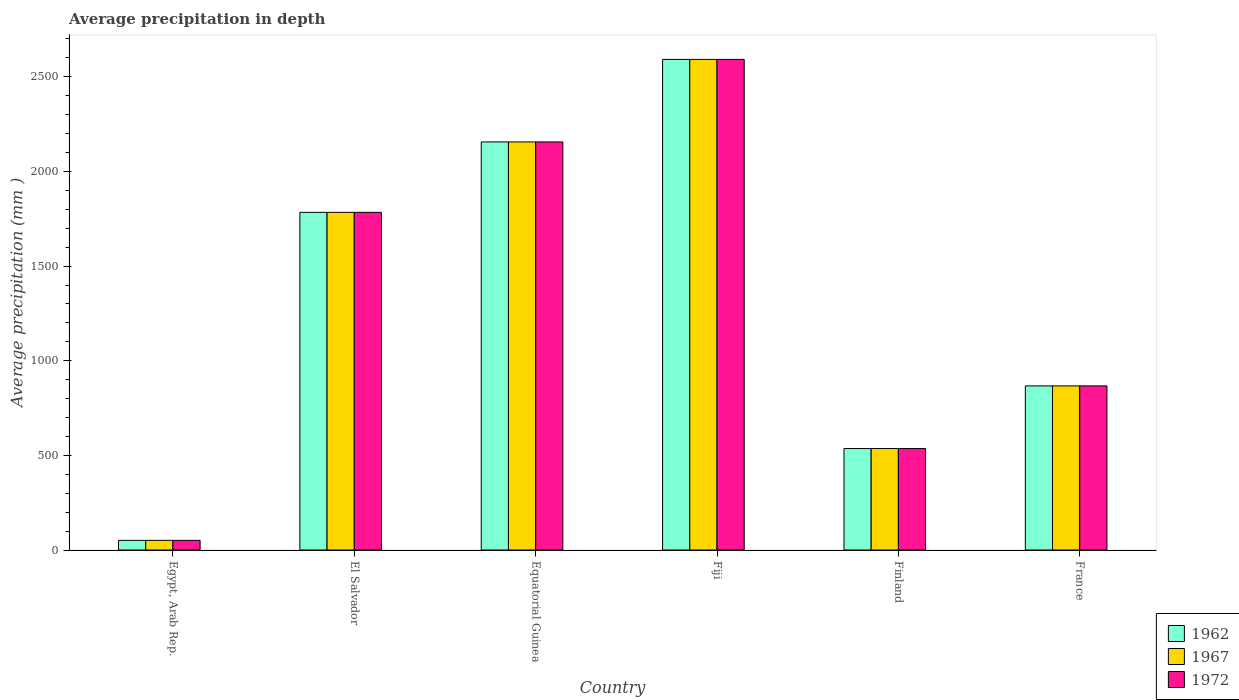Are the number of bars on each tick of the X-axis equal?
Provide a succinct answer. Yes. How many bars are there on the 4th tick from the right?
Make the answer very short. 3. What is the label of the 4th group of bars from the left?
Provide a short and direct response. Fiji. What is the average precipitation in 1962 in Equatorial Guinea?
Give a very brief answer. 2156. Across all countries, what is the maximum average precipitation in 1967?
Your answer should be very brief. 2592. Across all countries, what is the minimum average precipitation in 1962?
Offer a very short reply. 51. In which country was the average precipitation in 1967 maximum?
Your answer should be compact. Fiji. In which country was the average precipitation in 1962 minimum?
Give a very brief answer. Egypt, Arab Rep. What is the total average precipitation in 1962 in the graph?
Your answer should be very brief. 7986. What is the difference between the average precipitation in 1967 in El Salvador and that in Fiji?
Ensure brevity in your answer.  -808. What is the difference between the average precipitation in 1972 in Equatorial Guinea and the average precipitation in 1962 in Fiji?
Your response must be concise. -436. What is the average average precipitation in 1967 per country?
Keep it short and to the point. 1331. What is the difference between the average precipitation of/in 1967 and average precipitation of/in 1972 in Finland?
Your answer should be very brief. 0. In how many countries, is the average precipitation in 1972 greater than 500 mm?
Your answer should be very brief. 5. What is the ratio of the average precipitation in 1962 in El Salvador to that in Equatorial Guinea?
Keep it short and to the point. 0.83. Is the difference between the average precipitation in 1967 in Equatorial Guinea and France greater than the difference between the average precipitation in 1972 in Equatorial Guinea and France?
Your answer should be very brief. No. What is the difference between the highest and the second highest average precipitation in 1967?
Offer a terse response. 808. What is the difference between the highest and the lowest average precipitation in 1967?
Give a very brief answer. 2541. In how many countries, is the average precipitation in 1962 greater than the average average precipitation in 1962 taken over all countries?
Provide a succinct answer. 3. Is the sum of the average precipitation in 1972 in Fiji and France greater than the maximum average precipitation in 1962 across all countries?
Your response must be concise. Yes. What does the 3rd bar from the left in Equatorial Guinea represents?
Make the answer very short. 1972. How many bars are there?
Offer a terse response. 18. Are all the bars in the graph horizontal?
Your answer should be very brief. No. How many countries are there in the graph?
Offer a terse response. 6. Where does the legend appear in the graph?
Ensure brevity in your answer.  Bottom right. How are the legend labels stacked?
Keep it short and to the point. Vertical. What is the title of the graph?
Offer a terse response. Average precipitation in depth. Does "2007" appear as one of the legend labels in the graph?
Give a very brief answer. No. What is the label or title of the X-axis?
Make the answer very short. Country. What is the label or title of the Y-axis?
Make the answer very short. Average precipitation (mm ). What is the Average precipitation (mm ) in 1972 in Egypt, Arab Rep.?
Provide a short and direct response. 51. What is the Average precipitation (mm ) in 1962 in El Salvador?
Your response must be concise. 1784. What is the Average precipitation (mm ) in 1967 in El Salvador?
Your answer should be compact. 1784. What is the Average precipitation (mm ) of 1972 in El Salvador?
Give a very brief answer. 1784. What is the Average precipitation (mm ) of 1962 in Equatorial Guinea?
Make the answer very short. 2156. What is the Average precipitation (mm ) in 1967 in Equatorial Guinea?
Offer a terse response. 2156. What is the Average precipitation (mm ) of 1972 in Equatorial Guinea?
Provide a succinct answer. 2156. What is the Average precipitation (mm ) in 1962 in Fiji?
Your answer should be compact. 2592. What is the Average precipitation (mm ) of 1967 in Fiji?
Offer a terse response. 2592. What is the Average precipitation (mm ) of 1972 in Fiji?
Offer a very short reply. 2592. What is the Average precipitation (mm ) in 1962 in Finland?
Offer a very short reply. 536. What is the Average precipitation (mm ) in 1967 in Finland?
Provide a succinct answer. 536. What is the Average precipitation (mm ) in 1972 in Finland?
Your answer should be compact. 536. What is the Average precipitation (mm ) in 1962 in France?
Ensure brevity in your answer.  867. What is the Average precipitation (mm ) of 1967 in France?
Offer a very short reply. 867. What is the Average precipitation (mm ) in 1972 in France?
Provide a short and direct response. 867. Across all countries, what is the maximum Average precipitation (mm ) in 1962?
Keep it short and to the point. 2592. Across all countries, what is the maximum Average precipitation (mm ) of 1967?
Provide a succinct answer. 2592. Across all countries, what is the maximum Average precipitation (mm ) in 1972?
Provide a short and direct response. 2592. Across all countries, what is the minimum Average precipitation (mm ) of 1967?
Offer a very short reply. 51. Across all countries, what is the minimum Average precipitation (mm ) of 1972?
Provide a succinct answer. 51. What is the total Average precipitation (mm ) in 1962 in the graph?
Your response must be concise. 7986. What is the total Average precipitation (mm ) of 1967 in the graph?
Give a very brief answer. 7986. What is the total Average precipitation (mm ) of 1972 in the graph?
Keep it short and to the point. 7986. What is the difference between the Average precipitation (mm ) of 1962 in Egypt, Arab Rep. and that in El Salvador?
Your response must be concise. -1733. What is the difference between the Average precipitation (mm ) of 1967 in Egypt, Arab Rep. and that in El Salvador?
Your answer should be compact. -1733. What is the difference between the Average precipitation (mm ) of 1972 in Egypt, Arab Rep. and that in El Salvador?
Provide a short and direct response. -1733. What is the difference between the Average precipitation (mm ) in 1962 in Egypt, Arab Rep. and that in Equatorial Guinea?
Offer a terse response. -2105. What is the difference between the Average precipitation (mm ) in 1967 in Egypt, Arab Rep. and that in Equatorial Guinea?
Offer a terse response. -2105. What is the difference between the Average precipitation (mm ) in 1972 in Egypt, Arab Rep. and that in Equatorial Guinea?
Offer a terse response. -2105. What is the difference between the Average precipitation (mm ) of 1962 in Egypt, Arab Rep. and that in Fiji?
Keep it short and to the point. -2541. What is the difference between the Average precipitation (mm ) in 1967 in Egypt, Arab Rep. and that in Fiji?
Provide a short and direct response. -2541. What is the difference between the Average precipitation (mm ) of 1972 in Egypt, Arab Rep. and that in Fiji?
Ensure brevity in your answer.  -2541. What is the difference between the Average precipitation (mm ) in 1962 in Egypt, Arab Rep. and that in Finland?
Your answer should be compact. -485. What is the difference between the Average precipitation (mm ) of 1967 in Egypt, Arab Rep. and that in Finland?
Ensure brevity in your answer.  -485. What is the difference between the Average precipitation (mm ) in 1972 in Egypt, Arab Rep. and that in Finland?
Your answer should be compact. -485. What is the difference between the Average precipitation (mm ) of 1962 in Egypt, Arab Rep. and that in France?
Your answer should be very brief. -816. What is the difference between the Average precipitation (mm ) in 1967 in Egypt, Arab Rep. and that in France?
Your answer should be very brief. -816. What is the difference between the Average precipitation (mm ) in 1972 in Egypt, Arab Rep. and that in France?
Offer a very short reply. -816. What is the difference between the Average precipitation (mm ) in 1962 in El Salvador and that in Equatorial Guinea?
Give a very brief answer. -372. What is the difference between the Average precipitation (mm ) in 1967 in El Salvador and that in Equatorial Guinea?
Provide a short and direct response. -372. What is the difference between the Average precipitation (mm ) of 1972 in El Salvador and that in Equatorial Guinea?
Your answer should be compact. -372. What is the difference between the Average precipitation (mm ) in 1962 in El Salvador and that in Fiji?
Ensure brevity in your answer.  -808. What is the difference between the Average precipitation (mm ) of 1967 in El Salvador and that in Fiji?
Your answer should be compact. -808. What is the difference between the Average precipitation (mm ) of 1972 in El Salvador and that in Fiji?
Provide a short and direct response. -808. What is the difference between the Average precipitation (mm ) in 1962 in El Salvador and that in Finland?
Make the answer very short. 1248. What is the difference between the Average precipitation (mm ) in 1967 in El Salvador and that in Finland?
Provide a succinct answer. 1248. What is the difference between the Average precipitation (mm ) in 1972 in El Salvador and that in Finland?
Provide a succinct answer. 1248. What is the difference between the Average precipitation (mm ) in 1962 in El Salvador and that in France?
Make the answer very short. 917. What is the difference between the Average precipitation (mm ) of 1967 in El Salvador and that in France?
Offer a terse response. 917. What is the difference between the Average precipitation (mm ) in 1972 in El Salvador and that in France?
Provide a short and direct response. 917. What is the difference between the Average precipitation (mm ) in 1962 in Equatorial Guinea and that in Fiji?
Provide a succinct answer. -436. What is the difference between the Average precipitation (mm ) in 1967 in Equatorial Guinea and that in Fiji?
Provide a short and direct response. -436. What is the difference between the Average precipitation (mm ) in 1972 in Equatorial Guinea and that in Fiji?
Your answer should be very brief. -436. What is the difference between the Average precipitation (mm ) in 1962 in Equatorial Guinea and that in Finland?
Offer a very short reply. 1620. What is the difference between the Average precipitation (mm ) of 1967 in Equatorial Guinea and that in Finland?
Offer a terse response. 1620. What is the difference between the Average precipitation (mm ) in 1972 in Equatorial Guinea and that in Finland?
Your answer should be very brief. 1620. What is the difference between the Average precipitation (mm ) in 1962 in Equatorial Guinea and that in France?
Offer a terse response. 1289. What is the difference between the Average precipitation (mm ) in 1967 in Equatorial Guinea and that in France?
Give a very brief answer. 1289. What is the difference between the Average precipitation (mm ) of 1972 in Equatorial Guinea and that in France?
Ensure brevity in your answer.  1289. What is the difference between the Average precipitation (mm ) in 1962 in Fiji and that in Finland?
Keep it short and to the point. 2056. What is the difference between the Average precipitation (mm ) of 1967 in Fiji and that in Finland?
Your response must be concise. 2056. What is the difference between the Average precipitation (mm ) in 1972 in Fiji and that in Finland?
Ensure brevity in your answer.  2056. What is the difference between the Average precipitation (mm ) in 1962 in Fiji and that in France?
Give a very brief answer. 1725. What is the difference between the Average precipitation (mm ) of 1967 in Fiji and that in France?
Make the answer very short. 1725. What is the difference between the Average precipitation (mm ) in 1972 in Fiji and that in France?
Make the answer very short. 1725. What is the difference between the Average precipitation (mm ) of 1962 in Finland and that in France?
Your answer should be compact. -331. What is the difference between the Average precipitation (mm ) in 1967 in Finland and that in France?
Provide a short and direct response. -331. What is the difference between the Average precipitation (mm ) of 1972 in Finland and that in France?
Offer a terse response. -331. What is the difference between the Average precipitation (mm ) in 1962 in Egypt, Arab Rep. and the Average precipitation (mm ) in 1967 in El Salvador?
Offer a terse response. -1733. What is the difference between the Average precipitation (mm ) of 1962 in Egypt, Arab Rep. and the Average precipitation (mm ) of 1972 in El Salvador?
Offer a terse response. -1733. What is the difference between the Average precipitation (mm ) in 1967 in Egypt, Arab Rep. and the Average precipitation (mm ) in 1972 in El Salvador?
Make the answer very short. -1733. What is the difference between the Average precipitation (mm ) of 1962 in Egypt, Arab Rep. and the Average precipitation (mm ) of 1967 in Equatorial Guinea?
Give a very brief answer. -2105. What is the difference between the Average precipitation (mm ) of 1962 in Egypt, Arab Rep. and the Average precipitation (mm ) of 1972 in Equatorial Guinea?
Your response must be concise. -2105. What is the difference between the Average precipitation (mm ) in 1967 in Egypt, Arab Rep. and the Average precipitation (mm ) in 1972 in Equatorial Guinea?
Your answer should be very brief. -2105. What is the difference between the Average precipitation (mm ) of 1962 in Egypt, Arab Rep. and the Average precipitation (mm ) of 1967 in Fiji?
Give a very brief answer. -2541. What is the difference between the Average precipitation (mm ) of 1962 in Egypt, Arab Rep. and the Average precipitation (mm ) of 1972 in Fiji?
Offer a very short reply. -2541. What is the difference between the Average precipitation (mm ) of 1967 in Egypt, Arab Rep. and the Average precipitation (mm ) of 1972 in Fiji?
Your answer should be very brief. -2541. What is the difference between the Average precipitation (mm ) of 1962 in Egypt, Arab Rep. and the Average precipitation (mm ) of 1967 in Finland?
Give a very brief answer. -485. What is the difference between the Average precipitation (mm ) of 1962 in Egypt, Arab Rep. and the Average precipitation (mm ) of 1972 in Finland?
Provide a short and direct response. -485. What is the difference between the Average precipitation (mm ) of 1967 in Egypt, Arab Rep. and the Average precipitation (mm ) of 1972 in Finland?
Give a very brief answer. -485. What is the difference between the Average precipitation (mm ) in 1962 in Egypt, Arab Rep. and the Average precipitation (mm ) in 1967 in France?
Your answer should be very brief. -816. What is the difference between the Average precipitation (mm ) of 1962 in Egypt, Arab Rep. and the Average precipitation (mm ) of 1972 in France?
Ensure brevity in your answer.  -816. What is the difference between the Average precipitation (mm ) of 1967 in Egypt, Arab Rep. and the Average precipitation (mm ) of 1972 in France?
Offer a terse response. -816. What is the difference between the Average precipitation (mm ) in 1962 in El Salvador and the Average precipitation (mm ) in 1967 in Equatorial Guinea?
Offer a very short reply. -372. What is the difference between the Average precipitation (mm ) of 1962 in El Salvador and the Average precipitation (mm ) of 1972 in Equatorial Guinea?
Give a very brief answer. -372. What is the difference between the Average precipitation (mm ) of 1967 in El Salvador and the Average precipitation (mm ) of 1972 in Equatorial Guinea?
Make the answer very short. -372. What is the difference between the Average precipitation (mm ) in 1962 in El Salvador and the Average precipitation (mm ) in 1967 in Fiji?
Give a very brief answer. -808. What is the difference between the Average precipitation (mm ) of 1962 in El Salvador and the Average precipitation (mm ) of 1972 in Fiji?
Provide a short and direct response. -808. What is the difference between the Average precipitation (mm ) in 1967 in El Salvador and the Average precipitation (mm ) in 1972 in Fiji?
Your answer should be compact. -808. What is the difference between the Average precipitation (mm ) of 1962 in El Salvador and the Average precipitation (mm ) of 1967 in Finland?
Your answer should be compact. 1248. What is the difference between the Average precipitation (mm ) of 1962 in El Salvador and the Average precipitation (mm ) of 1972 in Finland?
Keep it short and to the point. 1248. What is the difference between the Average precipitation (mm ) in 1967 in El Salvador and the Average precipitation (mm ) in 1972 in Finland?
Keep it short and to the point. 1248. What is the difference between the Average precipitation (mm ) in 1962 in El Salvador and the Average precipitation (mm ) in 1967 in France?
Your answer should be compact. 917. What is the difference between the Average precipitation (mm ) of 1962 in El Salvador and the Average precipitation (mm ) of 1972 in France?
Your answer should be very brief. 917. What is the difference between the Average precipitation (mm ) of 1967 in El Salvador and the Average precipitation (mm ) of 1972 in France?
Your response must be concise. 917. What is the difference between the Average precipitation (mm ) of 1962 in Equatorial Guinea and the Average precipitation (mm ) of 1967 in Fiji?
Offer a terse response. -436. What is the difference between the Average precipitation (mm ) of 1962 in Equatorial Guinea and the Average precipitation (mm ) of 1972 in Fiji?
Your answer should be compact. -436. What is the difference between the Average precipitation (mm ) in 1967 in Equatorial Guinea and the Average precipitation (mm ) in 1972 in Fiji?
Give a very brief answer. -436. What is the difference between the Average precipitation (mm ) of 1962 in Equatorial Guinea and the Average precipitation (mm ) of 1967 in Finland?
Provide a short and direct response. 1620. What is the difference between the Average precipitation (mm ) of 1962 in Equatorial Guinea and the Average precipitation (mm ) of 1972 in Finland?
Provide a short and direct response. 1620. What is the difference between the Average precipitation (mm ) of 1967 in Equatorial Guinea and the Average precipitation (mm ) of 1972 in Finland?
Make the answer very short. 1620. What is the difference between the Average precipitation (mm ) in 1962 in Equatorial Guinea and the Average precipitation (mm ) in 1967 in France?
Your answer should be compact. 1289. What is the difference between the Average precipitation (mm ) of 1962 in Equatorial Guinea and the Average precipitation (mm ) of 1972 in France?
Offer a very short reply. 1289. What is the difference between the Average precipitation (mm ) of 1967 in Equatorial Guinea and the Average precipitation (mm ) of 1972 in France?
Provide a short and direct response. 1289. What is the difference between the Average precipitation (mm ) in 1962 in Fiji and the Average precipitation (mm ) in 1967 in Finland?
Make the answer very short. 2056. What is the difference between the Average precipitation (mm ) in 1962 in Fiji and the Average precipitation (mm ) in 1972 in Finland?
Your answer should be compact. 2056. What is the difference between the Average precipitation (mm ) of 1967 in Fiji and the Average precipitation (mm ) of 1972 in Finland?
Offer a terse response. 2056. What is the difference between the Average precipitation (mm ) of 1962 in Fiji and the Average precipitation (mm ) of 1967 in France?
Provide a succinct answer. 1725. What is the difference between the Average precipitation (mm ) of 1962 in Fiji and the Average precipitation (mm ) of 1972 in France?
Give a very brief answer. 1725. What is the difference between the Average precipitation (mm ) of 1967 in Fiji and the Average precipitation (mm ) of 1972 in France?
Give a very brief answer. 1725. What is the difference between the Average precipitation (mm ) of 1962 in Finland and the Average precipitation (mm ) of 1967 in France?
Ensure brevity in your answer.  -331. What is the difference between the Average precipitation (mm ) in 1962 in Finland and the Average precipitation (mm ) in 1972 in France?
Make the answer very short. -331. What is the difference between the Average precipitation (mm ) in 1967 in Finland and the Average precipitation (mm ) in 1972 in France?
Your response must be concise. -331. What is the average Average precipitation (mm ) of 1962 per country?
Provide a succinct answer. 1331. What is the average Average precipitation (mm ) of 1967 per country?
Your answer should be compact. 1331. What is the average Average precipitation (mm ) in 1972 per country?
Your answer should be compact. 1331. What is the difference between the Average precipitation (mm ) in 1967 and Average precipitation (mm ) in 1972 in Egypt, Arab Rep.?
Your response must be concise. 0. What is the difference between the Average precipitation (mm ) of 1962 and Average precipitation (mm ) of 1967 in El Salvador?
Offer a very short reply. 0. What is the difference between the Average precipitation (mm ) of 1962 and Average precipitation (mm ) of 1972 in El Salvador?
Make the answer very short. 0. What is the difference between the Average precipitation (mm ) in 1962 and Average precipitation (mm ) in 1972 in Equatorial Guinea?
Your answer should be very brief. 0. What is the difference between the Average precipitation (mm ) in 1962 and Average precipitation (mm ) in 1967 in Fiji?
Give a very brief answer. 0. What is the difference between the Average precipitation (mm ) of 1962 and Average precipitation (mm ) of 1967 in France?
Provide a succinct answer. 0. What is the ratio of the Average precipitation (mm ) of 1962 in Egypt, Arab Rep. to that in El Salvador?
Keep it short and to the point. 0.03. What is the ratio of the Average precipitation (mm ) in 1967 in Egypt, Arab Rep. to that in El Salvador?
Make the answer very short. 0.03. What is the ratio of the Average precipitation (mm ) in 1972 in Egypt, Arab Rep. to that in El Salvador?
Keep it short and to the point. 0.03. What is the ratio of the Average precipitation (mm ) of 1962 in Egypt, Arab Rep. to that in Equatorial Guinea?
Provide a succinct answer. 0.02. What is the ratio of the Average precipitation (mm ) of 1967 in Egypt, Arab Rep. to that in Equatorial Guinea?
Keep it short and to the point. 0.02. What is the ratio of the Average precipitation (mm ) of 1972 in Egypt, Arab Rep. to that in Equatorial Guinea?
Your answer should be very brief. 0.02. What is the ratio of the Average precipitation (mm ) in 1962 in Egypt, Arab Rep. to that in Fiji?
Provide a short and direct response. 0.02. What is the ratio of the Average precipitation (mm ) of 1967 in Egypt, Arab Rep. to that in Fiji?
Provide a succinct answer. 0.02. What is the ratio of the Average precipitation (mm ) in 1972 in Egypt, Arab Rep. to that in Fiji?
Ensure brevity in your answer.  0.02. What is the ratio of the Average precipitation (mm ) in 1962 in Egypt, Arab Rep. to that in Finland?
Give a very brief answer. 0.1. What is the ratio of the Average precipitation (mm ) of 1967 in Egypt, Arab Rep. to that in Finland?
Offer a very short reply. 0.1. What is the ratio of the Average precipitation (mm ) of 1972 in Egypt, Arab Rep. to that in Finland?
Make the answer very short. 0.1. What is the ratio of the Average precipitation (mm ) in 1962 in Egypt, Arab Rep. to that in France?
Your answer should be very brief. 0.06. What is the ratio of the Average precipitation (mm ) of 1967 in Egypt, Arab Rep. to that in France?
Your answer should be compact. 0.06. What is the ratio of the Average precipitation (mm ) in 1972 in Egypt, Arab Rep. to that in France?
Your answer should be compact. 0.06. What is the ratio of the Average precipitation (mm ) in 1962 in El Salvador to that in Equatorial Guinea?
Keep it short and to the point. 0.83. What is the ratio of the Average precipitation (mm ) of 1967 in El Salvador to that in Equatorial Guinea?
Ensure brevity in your answer.  0.83. What is the ratio of the Average precipitation (mm ) in 1972 in El Salvador to that in Equatorial Guinea?
Your answer should be very brief. 0.83. What is the ratio of the Average precipitation (mm ) in 1962 in El Salvador to that in Fiji?
Your answer should be compact. 0.69. What is the ratio of the Average precipitation (mm ) in 1967 in El Salvador to that in Fiji?
Keep it short and to the point. 0.69. What is the ratio of the Average precipitation (mm ) in 1972 in El Salvador to that in Fiji?
Ensure brevity in your answer.  0.69. What is the ratio of the Average precipitation (mm ) of 1962 in El Salvador to that in Finland?
Ensure brevity in your answer.  3.33. What is the ratio of the Average precipitation (mm ) of 1967 in El Salvador to that in Finland?
Provide a succinct answer. 3.33. What is the ratio of the Average precipitation (mm ) of 1972 in El Salvador to that in Finland?
Keep it short and to the point. 3.33. What is the ratio of the Average precipitation (mm ) in 1962 in El Salvador to that in France?
Ensure brevity in your answer.  2.06. What is the ratio of the Average precipitation (mm ) of 1967 in El Salvador to that in France?
Your response must be concise. 2.06. What is the ratio of the Average precipitation (mm ) in 1972 in El Salvador to that in France?
Provide a succinct answer. 2.06. What is the ratio of the Average precipitation (mm ) of 1962 in Equatorial Guinea to that in Fiji?
Keep it short and to the point. 0.83. What is the ratio of the Average precipitation (mm ) in 1967 in Equatorial Guinea to that in Fiji?
Provide a short and direct response. 0.83. What is the ratio of the Average precipitation (mm ) in 1972 in Equatorial Guinea to that in Fiji?
Offer a terse response. 0.83. What is the ratio of the Average precipitation (mm ) of 1962 in Equatorial Guinea to that in Finland?
Ensure brevity in your answer.  4.02. What is the ratio of the Average precipitation (mm ) in 1967 in Equatorial Guinea to that in Finland?
Ensure brevity in your answer.  4.02. What is the ratio of the Average precipitation (mm ) of 1972 in Equatorial Guinea to that in Finland?
Your answer should be compact. 4.02. What is the ratio of the Average precipitation (mm ) of 1962 in Equatorial Guinea to that in France?
Your response must be concise. 2.49. What is the ratio of the Average precipitation (mm ) of 1967 in Equatorial Guinea to that in France?
Offer a very short reply. 2.49. What is the ratio of the Average precipitation (mm ) of 1972 in Equatorial Guinea to that in France?
Offer a very short reply. 2.49. What is the ratio of the Average precipitation (mm ) in 1962 in Fiji to that in Finland?
Give a very brief answer. 4.84. What is the ratio of the Average precipitation (mm ) of 1967 in Fiji to that in Finland?
Provide a succinct answer. 4.84. What is the ratio of the Average precipitation (mm ) of 1972 in Fiji to that in Finland?
Your response must be concise. 4.84. What is the ratio of the Average precipitation (mm ) of 1962 in Fiji to that in France?
Your answer should be very brief. 2.99. What is the ratio of the Average precipitation (mm ) of 1967 in Fiji to that in France?
Provide a succinct answer. 2.99. What is the ratio of the Average precipitation (mm ) of 1972 in Fiji to that in France?
Offer a very short reply. 2.99. What is the ratio of the Average precipitation (mm ) of 1962 in Finland to that in France?
Give a very brief answer. 0.62. What is the ratio of the Average precipitation (mm ) of 1967 in Finland to that in France?
Offer a very short reply. 0.62. What is the ratio of the Average precipitation (mm ) in 1972 in Finland to that in France?
Keep it short and to the point. 0.62. What is the difference between the highest and the second highest Average precipitation (mm ) of 1962?
Offer a terse response. 436. What is the difference between the highest and the second highest Average precipitation (mm ) of 1967?
Your response must be concise. 436. What is the difference between the highest and the second highest Average precipitation (mm ) of 1972?
Your answer should be very brief. 436. What is the difference between the highest and the lowest Average precipitation (mm ) of 1962?
Provide a succinct answer. 2541. What is the difference between the highest and the lowest Average precipitation (mm ) in 1967?
Provide a short and direct response. 2541. What is the difference between the highest and the lowest Average precipitation (mm ) of 1972?
Make the answer very short. 2541. 